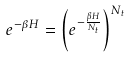<formula> <loc_0><loc_0><loc_500><loc_500>e ^ { - \beta H } = \left ( e ^ { - \frac { \beta H } { N _ { t } } } \right ) ^ { N _ { t } }</formula> 